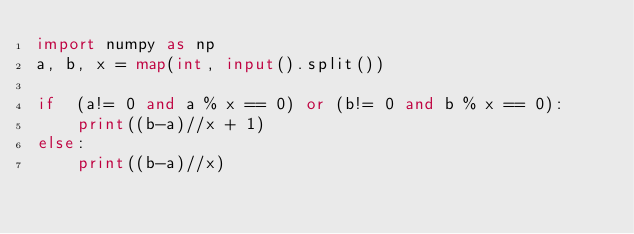<code> <loc_0><loc_0><loc_500><loc_500><_Python_>import numpy as np
a, b, x = map(int, input().split())

if  (a!= 0 and a % x == 0) or (b!= 0 and b % x == 0):
    print((b-a)//x + 1)
else:
    print((b-a)//x)</code> 